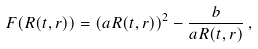<formula> <loc_0><loc_0><loc_500><loc_500>F ( R ( t , r ) ) = ( a R ( t , r ) ) ^ { 2 } - \frac { b } { a R ( t , r ) } \, ,</formula> 